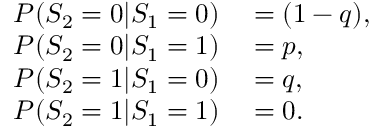Convert formula to latex. <formula><loc_0><loc_0><loc_500><loc_500>\begin{array} { r l } { P ( S _ { 2 } = 0 | S _ { 1 } = 0 ) } & = ( 1 - q ) , } \\ { P ( S _ { 2 } = 0 | S _ { 1 } = 1 ) } & = p , } \\ { P ( S _ { 2 } = 1 | S _ { 1 } = 0 ) } & = q , } \\ { P ( S _ { 2 } = 1 | S _ { 1 } = 1 ) } & = 0 . } \end{array}</formula> 